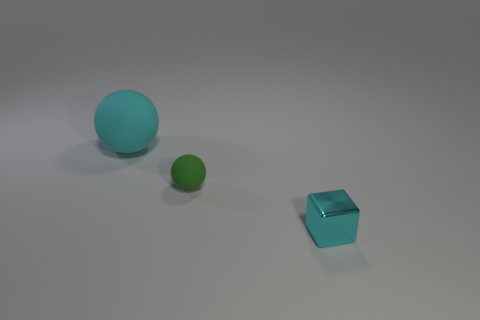Add 1 large red cylinders. How many objects exist? 4 Subtract all cubes. How many objects are left? 2 Add 2 tiny green things. How many tiny green things are left? 3 Add 1 large yellow things. How many large yellow things exist? 1 Subtract 0 green cylinders. How many objects are left? 3 Subtract all yellow metallic objects. Subtract all small rubber balls. How many objects are left? 2 